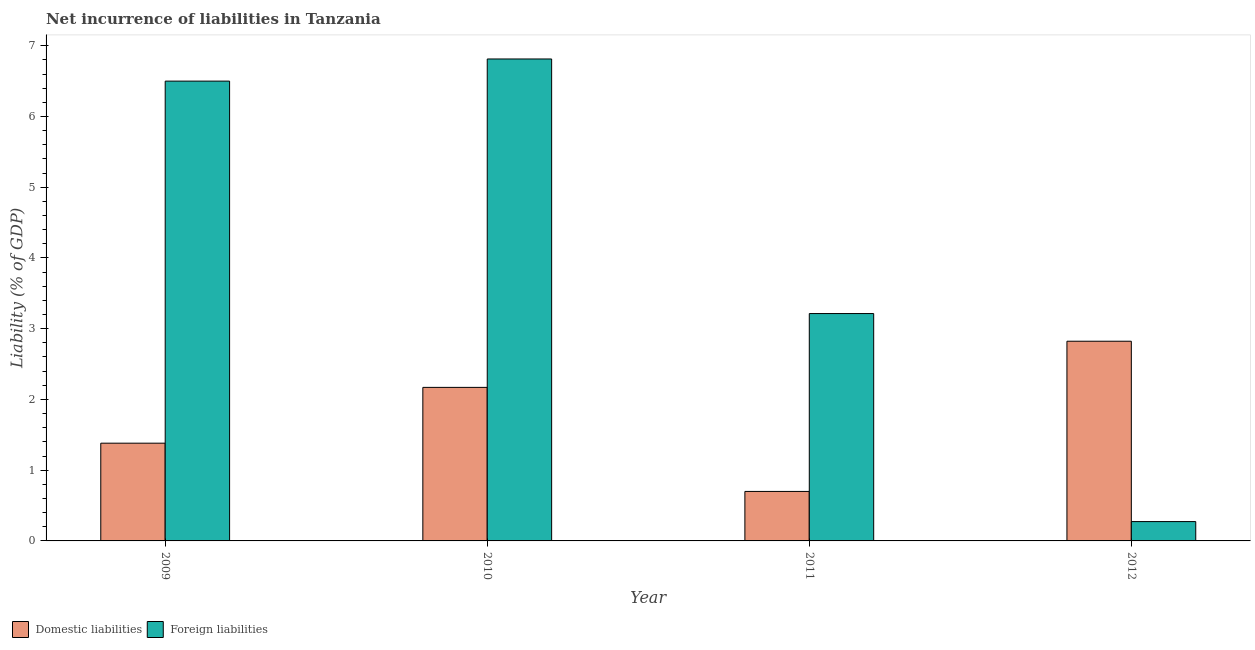How many different coloured bars are there?
Keep it short and to the point. 2. How many bars are there on the 2nd tick from the left?
Make the answer very short. 2. How many bars are there on the 3rd tick from the right?
Give a very brief answer. 2. What is the label of the 3rd group of bars from the left?
Give a very brief answer. 2011. What is the incurrence of foreign liabilities in 2012?
Give a very brief answer. 0.27. Across all years, what is the maximum incurrence of foreign liabilities?
Provide a short and direct response. 6.81. Across all years, what is the minimum incurrence of domestic liabilities?
Your answer should be compact. 0.7. In which year was the incurrence of foreign liabilities maximum?
Provide a succinct answer. 2010. In which year was the incurrence of foreign liabilities minimum?
Provide a succinct answer. 2012. What is the total incurrence of foreign liabilities in the graph?
Your answer should be compact. 16.8. What is the difference between the incurrence of foreign liabilities in 2009 and that in 2011?
Make the answer very short. 3.29. What is the difference between the incurrence of foreign liabilities in 2012 and the incurrence of domestic liabilities in 2010?
Keep it short and to the point. -6.54. What is the average incurrence of domestic liabilities per year?
Your answer should be very brief. 1.77. What is the ratio of the incurrence of foreign liabilities in 2010 to that in 2012?
Provide a short and direct response. 24.93. Is the incurrence of foreign liabilities in 2009 less than that in 2010?
Provide a succinct answer. Yes. What is the difference between the highest and the second highest incurrence of foreign liabilities?
Provide a short and direct response. 0.31. What is the difference between the highest and the lowest incurrence of foreign liabilities?
Give a very brief answer. 6.54. In how many years, is the incurrence of domestic liabilities greater than the average incurrence of domestic liabilities taken over all years?
Ensure brevity in your answer.  2. Is the sum of the incurrence of domestic liabilities in 2009 and 2010 greater than the maximum incurrence of foreign liabilities across all years?
Provide a succinct answer. Yes. What does the 2nd bar from the left in 2009 represents?
Your answer should be very brief. Foreign liabilities. What does the 2nd bar from the right in 2012 represents?
Provide a short and direct response. Domestic liabilities. How many bars are there?
Your answer should be very brief. 8. How many years are there in the graph?
Your answer should be compact. 4. Are the values on the major ticks of Y-axis written in scientific E-notation?
Give a very brief answer. No. Does the graph contain any zero values?
Ensure brevity in your answer.  No. Does the graph contain grids?
Ensure brevity in your answer.  No. What is the title of the graph?
Your answer should be compact. Net incurrence of liabilities in Tanzania. What is the label or title of the X-axis?
Offer a very short reply. Year. What is the label or title of the Y-axis?
Your answer should be compact. Liability (% of GDP). What is the Liability (% of GDP) of Domestic liabilities in 2009?
Provide a short and direct response. 1.38. What is the Liability (% of GDP) of Foreign liabilities in 2009?
Offer a terse response. 6.5. What is the Liability (% of GDP) of Domestic liabilities in 2010?
Your answer should be very brief. 2.17. What is the Liability (% of GDP) of Foreign liabilities in 2010?
Your response must be concise. 6.81. What is the Liability (% of GDP) in Domestic liabilities in 2011?
Offer a terse response. 0.7. What is the Liability (% of GDP) of Foreign liabilities in 2011?
Offer a very short reply. 3.21. What is the Liability (% of GDP) of Domestic liabilities in 2012?
Offer a terse response. 2.82. What is the Liability (% of GDP) of Foreign liabilities in 2012?
Offer a very short reply. 0.27. Across all years, what is the maximum Liability (% of GDP) in Domestic liabilities?
Make the answer very short. 2.82. Across all years, what is the maximum Liability (% of GDP) in Foreign liabilities?
Keep it short and to the point. 6.81. Across all years, what is the minimum Liability (% of GDP) of Domestic liabilities?
Provide a succinct answer. 0.7. Across all years, what is the minimum Liability (% of GDP) in Foreign liabilities?
Provide a succinct answer. 0.27. What is the total Liability (% of GDP) in Domestic liabilities in the graph?
Your response must be concise. 7.07. What is the total Liability (% of GDP) in Foreign liabilities in the graph?
Give a very brief answer. 16.8. What is the difference between the Liability (% of GDP) of Domestic liabilities in 2009 and that in 2010?
Your response must be concise. -0.79. What is the difference between the Liability (% of GDP) of Foreign liabilities in 2009 and that in 2010?
Ensure brevity in your answer.  -0.31. What is the difference between the Liability (% of GDP) of Domestic liabilities in 2009 and that in 2011?
Provide a short and direct response. 0.68. What is the difference between the Liability (% of GDP) in Foreign liabilities in 2009 and that in 2011?
Give a very brief answer. 3.29. What is the difference between the Liability (% of GDP) of Domestic liabilities in 2009 and that in 2012?
Your answer should be very brief. -1.44. What is the difference between the Liability (% of GDP) in Foreign liabilities in 2009 and that in 2012?
Your answer should be very brief. 6.23. What is the difference between the Liability (% of GDP) in Domestic liabilities in 2010 and that in 2011?
Keep it short and to the point. 1.47. What is the difference between the Liability (% of GDP) of Foreign liabilities in 2010 and that in 2011?
Give a very brief answer. 3.6. What is the difference between the Liability (% of GDP) in Domestic liabilities in 2010 and that in 2012?
Give a very brief answer. -0.65. What is the difference between the Liability (% of GDP) in Foreign liabilities in 2010 and that in 2012?
Your response must be concise. 6.54. What is the difference between the Liability (% of GDP) in Domestic liabilities in 2011 and that in 2012?
Provide a succinct answer. -2.12. What is the difference between the Liability (% of GDP) in Foreign liabilities in 2011 and that in 2012?
Ensure brevity in your answer.  2.94. What is the difference between the Liability (% of GDP) of Domestic liabilities in 2009 and the Liability (% of GDP) of Foreign liabilities in 2010?
Provide a succinct answer. -5.43. What is the difference between the Liability (% of GDP) in Domestic liabilities in 2009 and the Liability (% of GDP) in Foreign liabilities in 2011?
Offer a very short reply. -1.83. What is the difference between the Liability (% of GDP) in Domestic liabilities in 2009 and the Liability (% of GDP) in Foreign liabilities in 2012?
Offer a terse response. 1.11. What is the difference between the Liability (% of GDP) of Domestic liabilities in 2010 and the Liability (% of GDP) of Foreign liabilities in 2011?
Provide a short and direct response. -1.04. What is the difference between the Liability (% of GDP) in Domestic liabilities in 2010 and the Liability (% of GDP) in Foreign liabilities in 2012?
Your answer should be very brief. 1.9. What is the difference between the Liability (% of GDP) of Domestic liabilities in 2011 and the Liability (% of GDP) of Foreign liabilities in 2012?
Give a very brief answer. 0.43. What is the average Liability (% of GDP) in Domestic liabilities per year?
Offer a very short reply. 1.77. What is the average Liability (% of GDP) in Foreign liabilities per year?
Offer a very short reply. 4.2. In the year 2009, what is the difference between the Liability (% of GDP) of Domestic liabilities and Liability (% of GDP) of Foreign liabilities?
Your answer should be very brief. -5.12. In the year 2010, what is the difference between the Liability (% of GDP) in Domestic liabilities and Liability (% of GDP) in Foreign liabilities?
Make the answer very short. -4.64. In the year 2011, what is the difference between the Liability (% of GDP) in Domestic liabilities and Liability (% of GDP) in Foreign liabilities?
Make the answer very short. -2.51. In the year 2012, what is the difference between the Liability (% of GDP) in Domestic liabilities and Liability (% of GDP) in Foreign liabilities?
Your response must be concise. 2.55. What is the ratio of the Liability (% of GDP) in Domestic liabilities in 2009 to that in 2010?
Offer a terse response. 0.64. What is the ratio of the Liability (% of GDP) in Foreign liabilities in 2009 to that in 2010?
Give a very brief answer. 0.95. What is the ratio of the Liability (% of GDP) of Domestic liabilities in 2009 to that in 2011?
Keep it short and to the point. 1.98. What is the ratio of the Liability (% of GDP) of Foreign liabilities in 2009 to that in 2011?
Offer a very short reply. 2.02. What is the ratio of the Liability (% of GDP) of Domestic liabilities in 2009 to that in 2012?
Provide a short and direct response. 0.49. What is the ratio of the Liability (% of GDP) in Foreign liabilities in 2009 to that in 2012?
Provide a succinct answer. 23.78. What is the ratio of the Liability (% of GDP) in Domestic liabilities in 2010 to that in 2011?
Make the answer very short. 3.1. What is the ratio of the Liability (% of GDP) of Foreign liabilities in 2010 to that in 2011?
Ensure brevity in your answer.  2.12. What is the ratio of the Liability (% of GDP) in Domestic liabilities in 2010 to that in 2012?
Provide a succinct answer. 0.77. What is the ratio of the Liability (% of GDP) in Foreign liabilities in 2010 to that in 2012?
Ensure brevity in your answer.  24.93. What is the ratio of the Liability (% of GDP) in Domestic liabilities in 2011 to that in 2012?
Offer a very short reply. 0.25. What is the ratio of the Liability (% of GDP) of Foreign liabilities in 2011 to that in 2012?
Give a very brief answer. 11.76. What is the difference between the highest and the second highest Liability (% of GDP) of Domestic liabilities?
Ensure brevity in your answer.  0.65. What is the difference between the highest and the second highest Liability (% of GDP) of Foreign liabilities?
Ensure brevity in your answer.  0.31. What is the difference between the highest and the lowest Liability (% of GDP) in Domestic liabilities?
Give a very brief answer. 2.12. What is the difference between the highest and the lowest Liability (% of GDP) of Foreign liabilities?
Give a very brief answer. 6.54. 